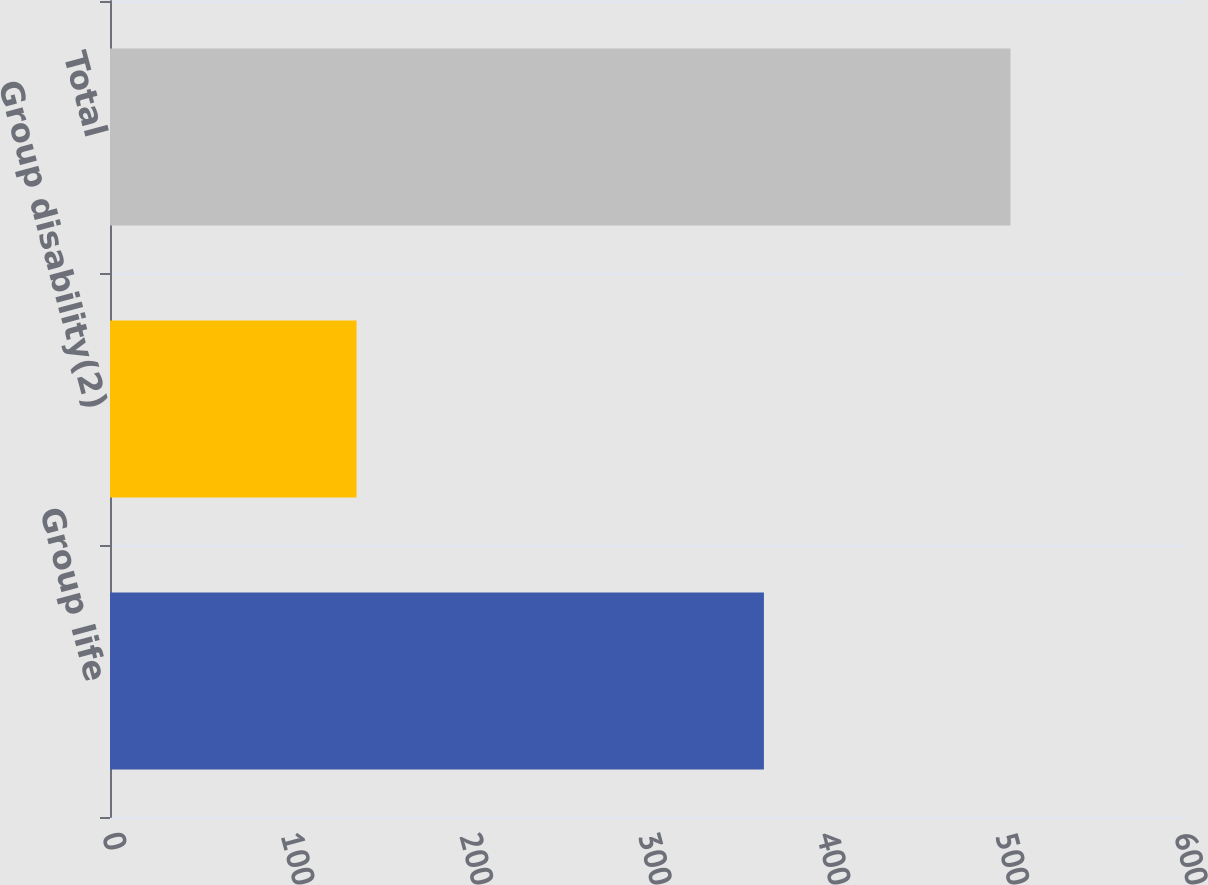Convert chart. <chart><loc_0><loc_0><loc_500><loc_500><bar_chart><fcel>Group life<fcel>Group disability(2)<fcel>Total<nl><fcel>366<fcel>138<fcel>504<nl></chart> 